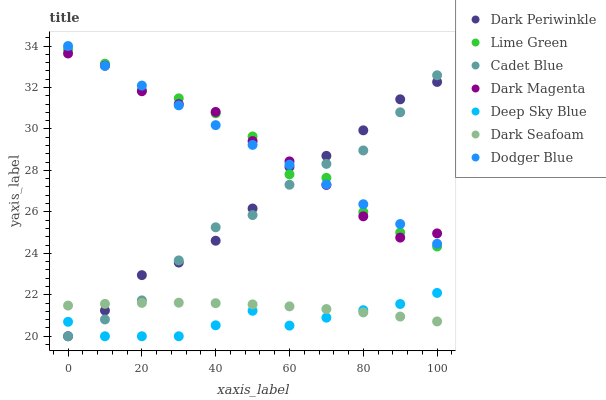Does Deep Sky Blue have the minimum area under the curve?
Answer yes or no. Yes. Does Lime Green have the maximum area under the curve?
Answer yes or no. Yes. Does Dark Magenta have the minimum area under the curve?
Answer yes or no. No. Does Dark Magenta have the maximum area under the curve?
Answer yes or no. No. Is Dodger Blue the smoothest?
Answer yes or no. Yes. Is Lime Green the roughest?
Answer yes or no. Yes. Is Dark Magenta the smoothest?
Answer yes or no. No. Is Dark Magenta the roughest?
Answer yes or no. No. Does Cadet Blue have the lowest value?
Answer yes or no. Yes. Does Dark Seafoam have the lowest value?
Answer yes or no. No. Does Dodger Blue have the highest value?
Answer yes or no. Yes. Does Dark Magenta have the highest value?
Answer yes or no. No. Is Deep Sky Blue less than Dodger Blue?
Answer yes or no. Yes. Is Dark Magenta greater than Dark Seafoam?
Answer yes or no. Yes. Does Dodger Blue intersect Dark Magenta?
Answer yes or no. Yes. Is Dodger Blue less than Dark Magenta?
Answer yes or no. No. Is Dodger Blue greater than Dark Magenta?
Answer yes or no. No. Does Deep Sky Blue intersect Dodger Blue?
Answer yes or no. No. 